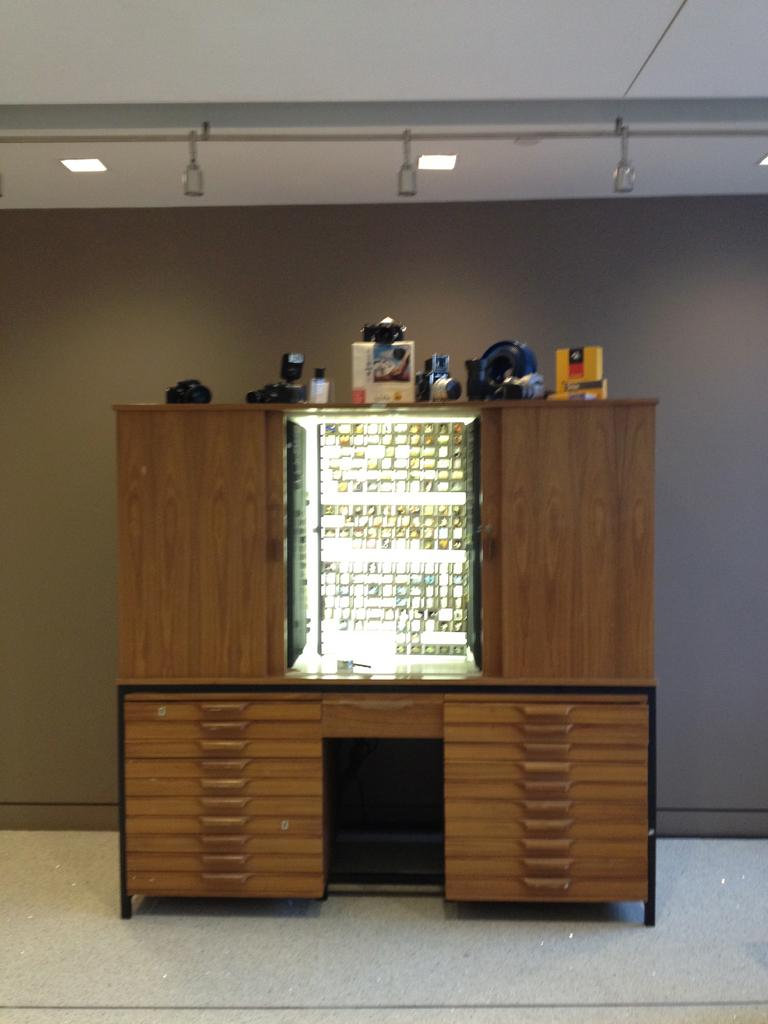What is the main structure in the image? There is a stand in the image. What is on the stand? Objects are placed on the stand. What can be seen in the background of the image? There is a wall and lights visible in the background of the image. Can you see a loaf of bread floating in the sea in the image? There is no sea or loaf of bread present in the image. 